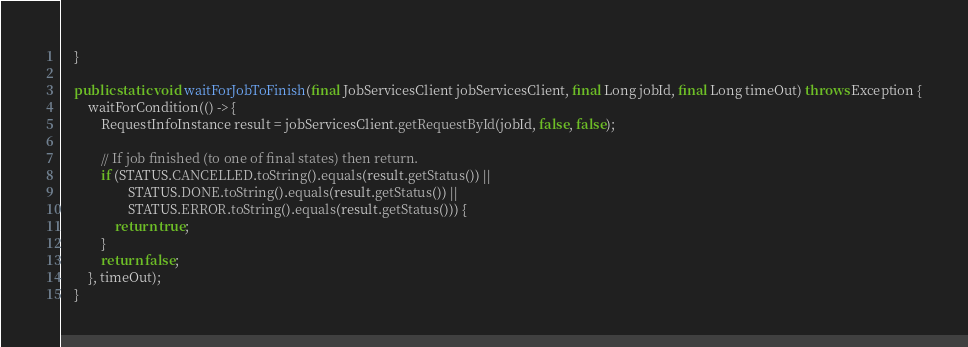<code> <loc_0><loc_0><loc_500><loc_500><_Java_>    }

    public static void waitForJobToFinish(final JobServicesClient jobServicesClient, final Long jobId, final Long timeOut) throws Exception {
        waitForCondition(() -> {
            RequestInfoInstance result = jobServicesClient.getRequestById(jobId, false, false);

            // If job finished (to one of final states) then return.
            if (STATUS.CANCELLED.toString().equals(result.getStatus()) ||
                    STATUS.DONE.toString().equals(result.getStatus()) ||
                    STATUS.ERROR.toString().equals(result.getStatus())) {
                return true;
            }
            return false;
        }, timeOut);
    }
</code> 